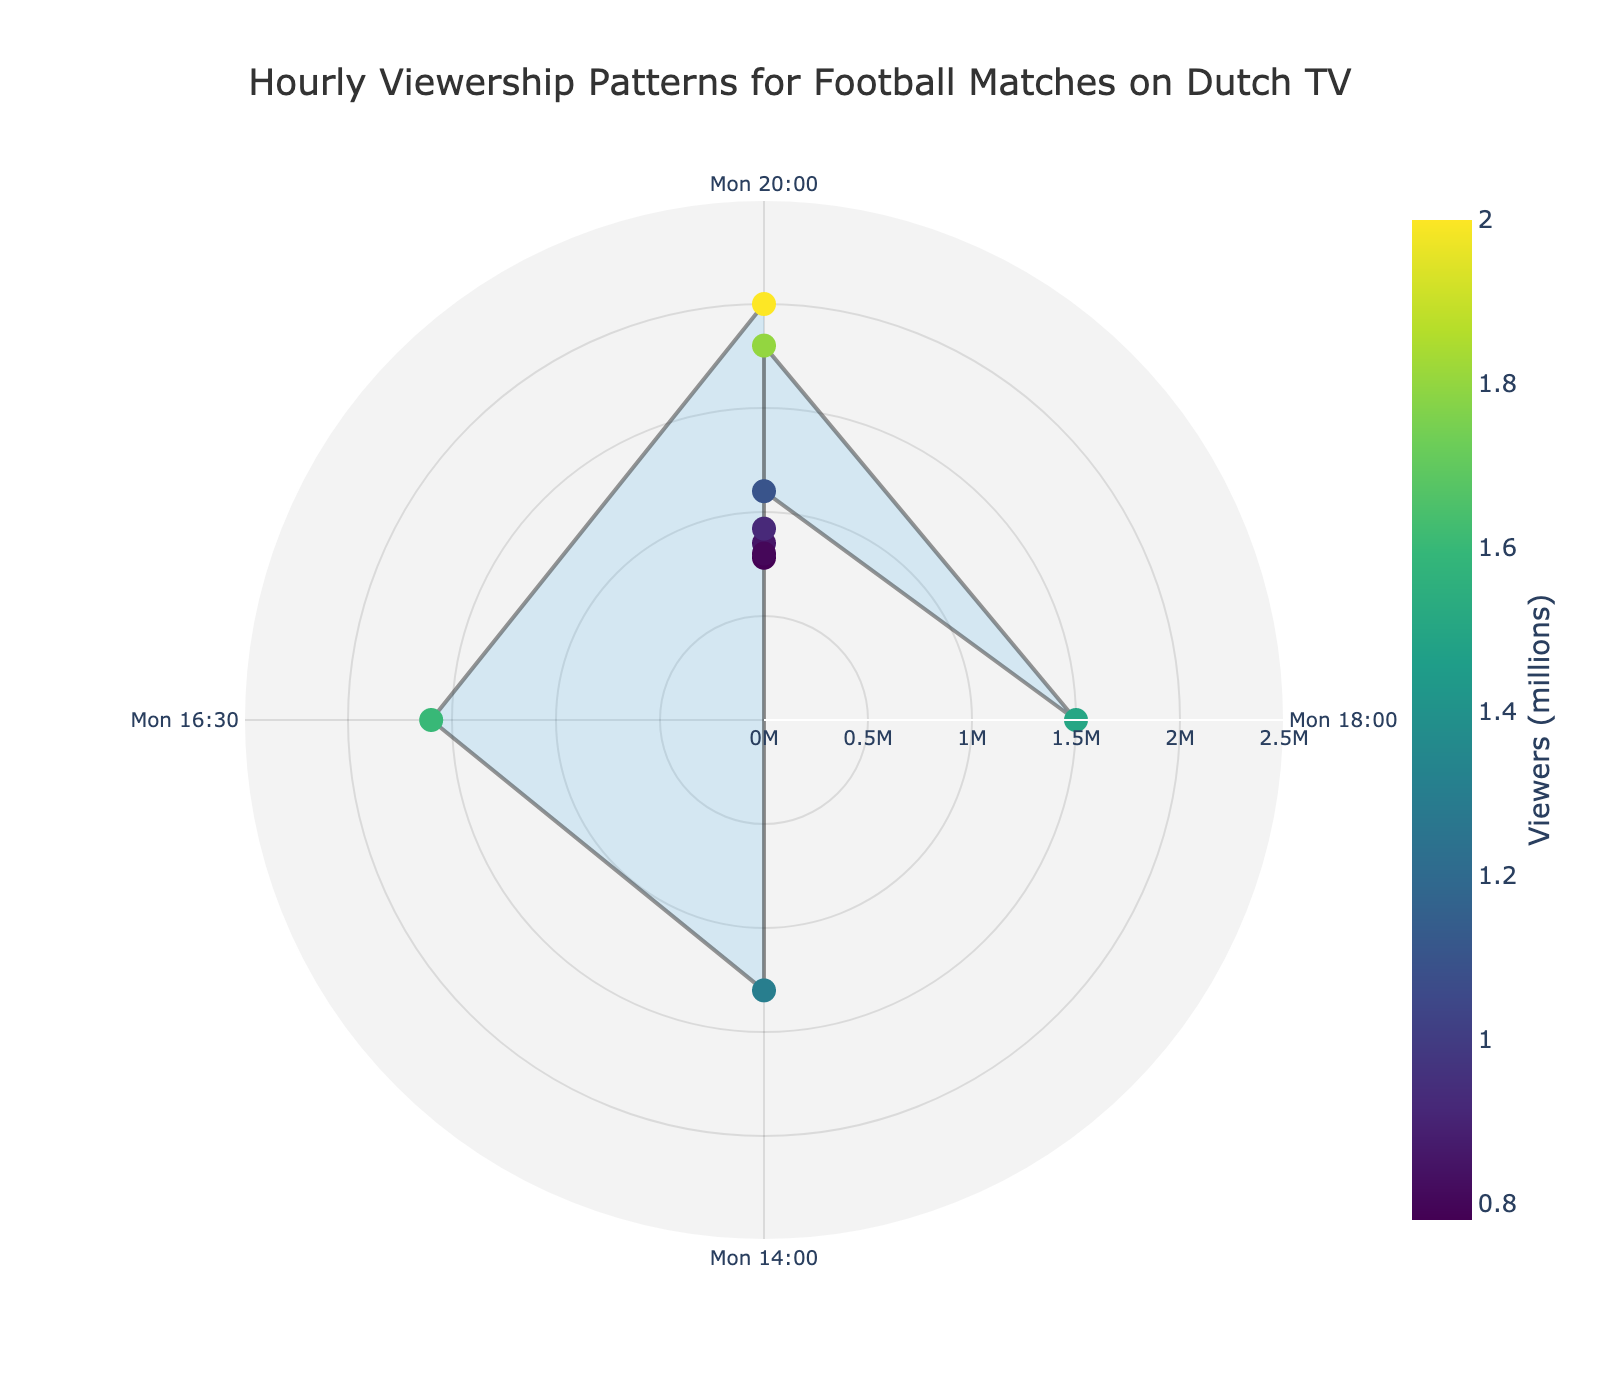What's the title of the figure? The title is located at the top of the figure and is visually prominent. It helps in understanding the context of the data presented in the figure.
Answer: Hourly Viewership Patterns for Football Matches on Dutch TV What is the peak viewership time and how many viewers does it have? To find the peak viewership time, look for the highest data point within the chart. The color scale and the labels further help in verifying the value. The peak viewership occurs at Sunday 20:00, and by checking the viewership scale, it shows 2 million viewers.
Answer: Sunday 20:00, 2 million What's the average viewership for football matches on weekends (Saturday and Sunday)? First, identify and sum the viewership figures for all Saturday and Sunday time slots: Saturday 18:00 (1.5M), Saturday 20:00 (1.8M), Sunday 14:00 (1.3M), Sunday 16:30 (1.6M), Sunday 20:00 (2.0M). Then, divide the sum by the number of data points, which is 5. Thus, (1.5M + 1.8M + 1.3M + 1.6M + 2.0M) / 5 = 1.64 million.
Answer: 1.64 million What is the viewership difference between Friday 20:00 and Monday 20:00? To calculate the difference in viewership, locate the values for both times: Friday 20:00 (1.1M) and Monday 20:00 (0.85M). Subtract the smaller value from the larger value: 1.1M - 0.85M = 0.25M.
Answer: 0.25 million Which day has the lowest viewership, and what is the viewership figure? Identify the smallest data point on the chart which corresponds to the lowest viewership. In this case, it is Monday 20:00 with 0.85 million viewers.
Answer: Monday, 0.85 million How does the viewership on Tuesday 20:00 compare to that on Thursday 20:00? Compare both data points to see which is higher. Tuesday 20:00 has 0.78 million viewers and Thursday 20:00 has 0.8 million viewers. Therefore, Thursday has slightly higher viewership.
Answer: Thursday is higher What is the total combined viewership for all Wednesday and Thursday matches? Locate the viewership figures for Wednesday 20:00 (0.92M) and Thursday 20:00 (0.8M). Add them together to get the total combined viewership: 0.92M + 0.8M = 1.72 million.
Answer: 1.72 million On average, how many more viewers watch football on Sundays compared to Tuesdays? First, find the average viewership for Sunday: (1.3M + 1.6M + 2.0M) / 3 = 1.63 million. Then, note the viewership for Tuesday is 0.78 million. Subtract Tuesday’s viewership from the average Sunday viewership: 1.63M - 0.78M = 0.85 million.
Answer: 0.85 million Which two weekdays have the closest viewership figures, and what are those figures? Compare each weekday's viewership to find the two closest values. Monday 20:00 (0.85M) and Tuesday 20:00 (0.78M) are the closest. The difference is only 0.07 million.
Answer: Monday (0.85M) and Tuesday (0.78M) What pattern or trend is observed in football viewership over the week? Observe the changes in viewership across the days of the week. It starts relatively lower on weekdays, increases notably on Friday, reaches peak values on the weekend, specifically on Sunday night.
Answer: Increasing trend towards the weekend 